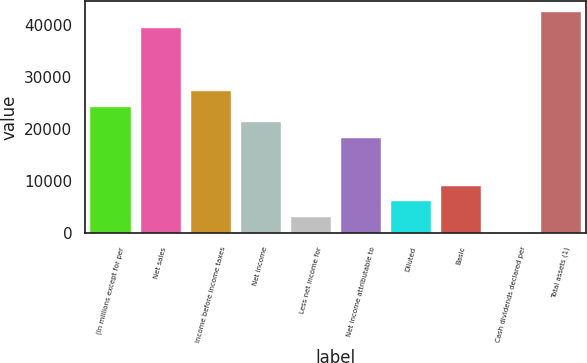Convert chart. <chart><loc_0><loc_0><loc_500><loc_500><bar_chart><fcel>(In millions except for per<fcel>Net sales<fcel>Income before income taxes<fcel>Net income<fcel>Less net income for<fcel>Net income attributable to<fcel>Diluted<fcel>Basic<fcel>Cash dividends declared per<fcel>Total assets (1)<nl><fcel>24335.6<fcel>39544<fcel>27377.3<fcel>21294<fcel>3043.95<fcel>18252.3<fcel>6085.62<fcel>9127.29<fcel>2.28<fcel>42585.7<nl></chart> 